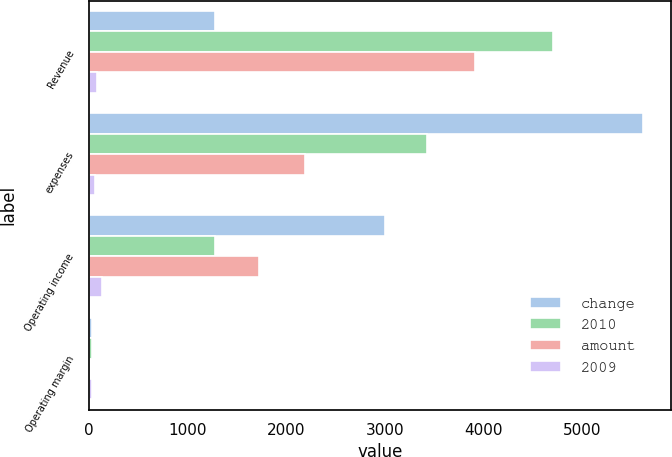Convert chart to OTSL. <chart><loc_0><loc_0><loc_500><loc_500><stacked_bar_chart><ecel><fcel>Revenue<fcel>expenses<fcel>Operating income<fcel>Operating margin<nl><fcel>change<fcel>1278<fcel>5614<fcel>2998<fcel>34.8<nl><fcel>2010<fcel>4700<fcel>3422<fcel>1278<fcel>27.2<nl><fcel>amount<fcel>3912<fcel>2192<fcel>1720<fcel>7.6<nl><fcel>2009<fcel>83<fcel>64<fcel>135<fcel>28<nl></chart> 